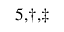Convert formula to latex. <formula><loc_0><loc_0><loc_500><loc_500>^ { 5 , \dagger , \ddagger }</formula> 